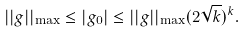Convert formula to latex. <formula><loc_0><loc_0><loc_500><loc_500>| | g | | _ { \max } \leq | g _ { 0 } | \leq | | g | | _ { \max } ( 2 \sqrt { k } ) ^ { k } .</formula> 